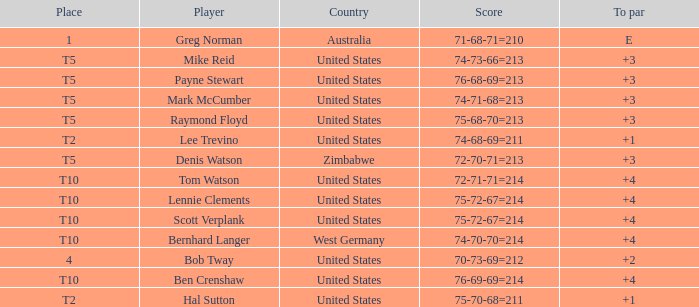What is player raymond floyd's country? United States. 